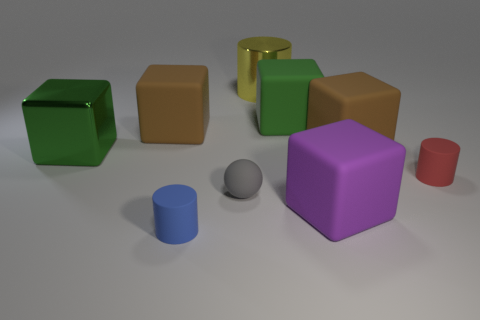Subtract all large green metal blocks. How many blocks are left? 4 Subtract all yellow blocks. Subtract all yellow spheres. How many blocks are left? 5 Add 1 big brown matte things. How many objects exist? 10 Subtract all cylinders. How many objects are left? 6 Subtract all red shiny things. Subtract all big green metallic cubes. How many objects are left? 8 Add 6 big green metal objects. How many big green metal objects are left? 7 Add 7 big green objects. How many big green objects exist? 9 Subtract 1 blue cylinders. How many objects are left? 8 